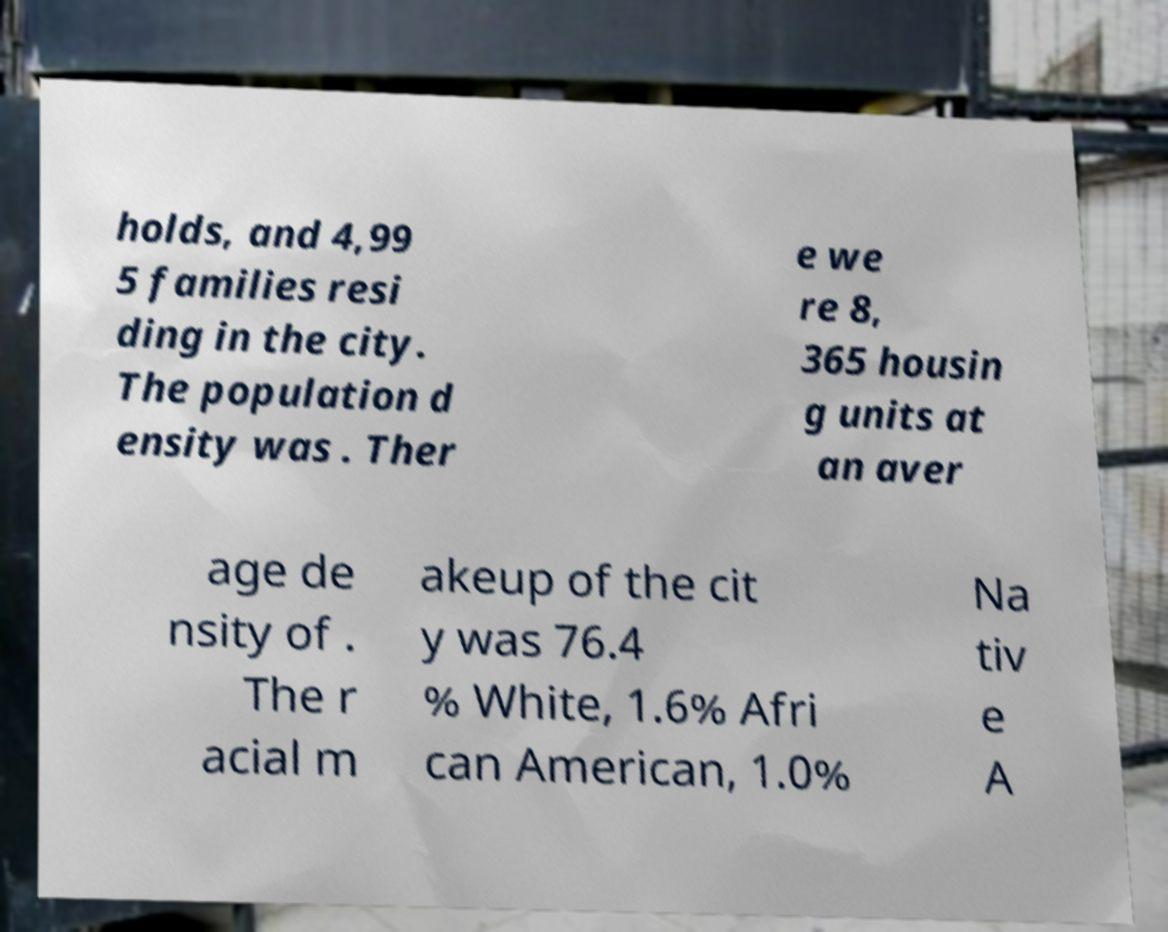Could you assist in decoding the text presented in this image and type it out clearly? holds, and 4,99 5 families resi ding in the city. The population d ensity was . Ther e we re 8, 365 housin g units at an aver age de nsity of . The r acial m akeup of the cit y was 76.4 % White, 1.6% Afri can American, 1.0% Na tiv e A 